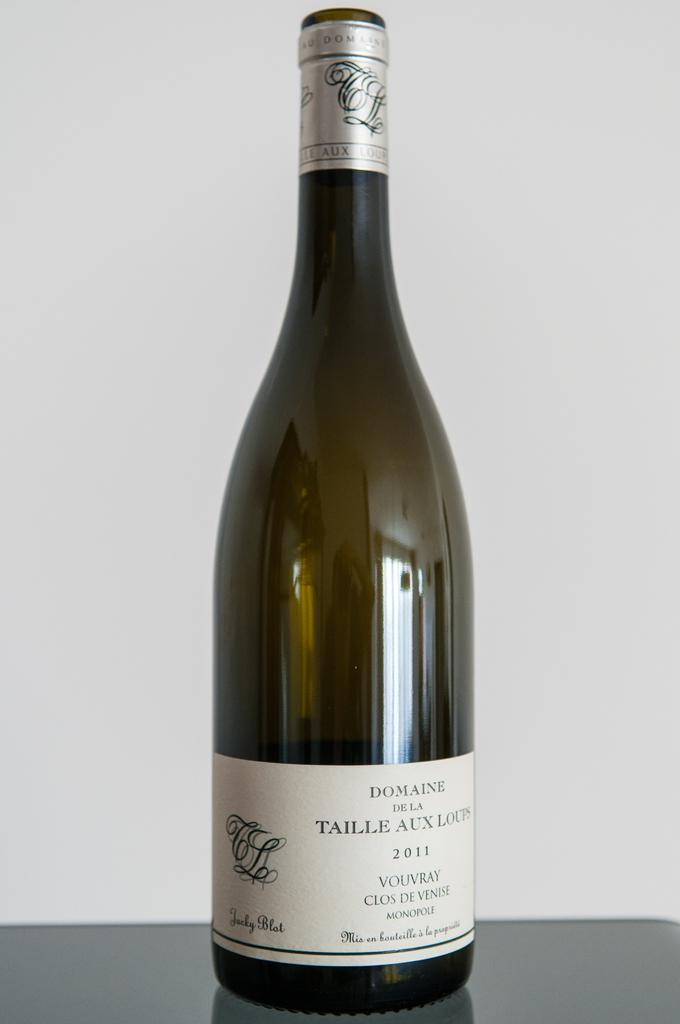<image>
Describe the image concisely. a bottle of wine with the word Domaine on the label. 